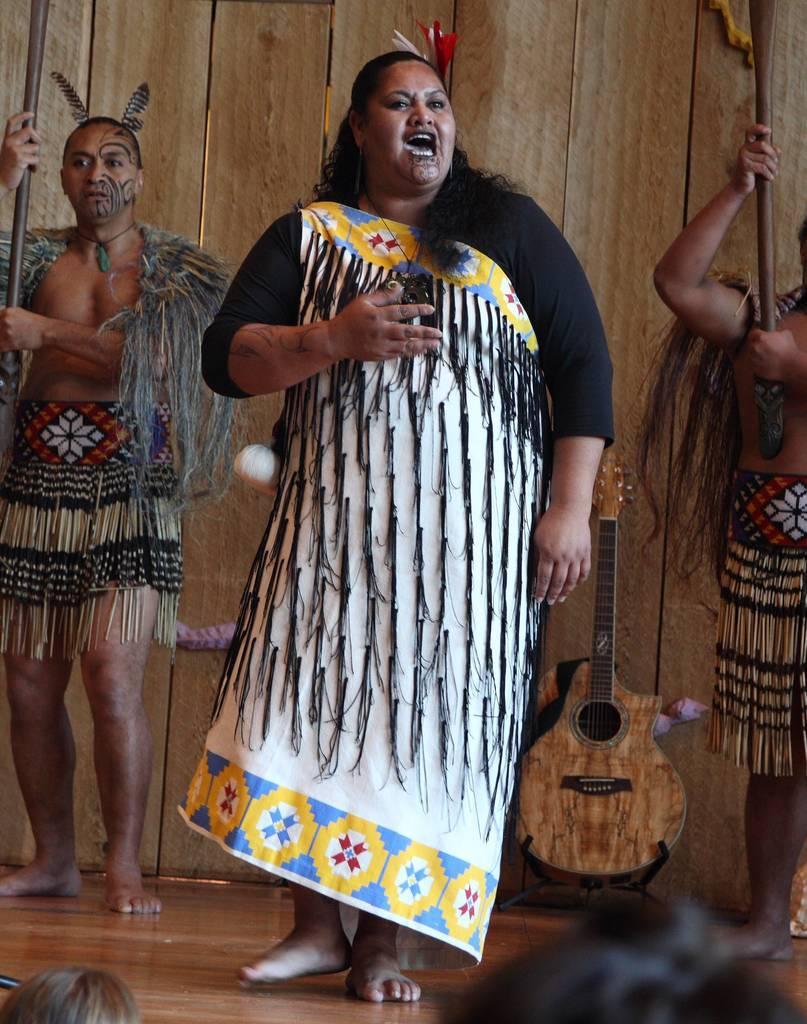Describe this image in one or two sentences. In the image we can see three persons were standing and they were smiling. In the background there is a wood wall and guitar. 